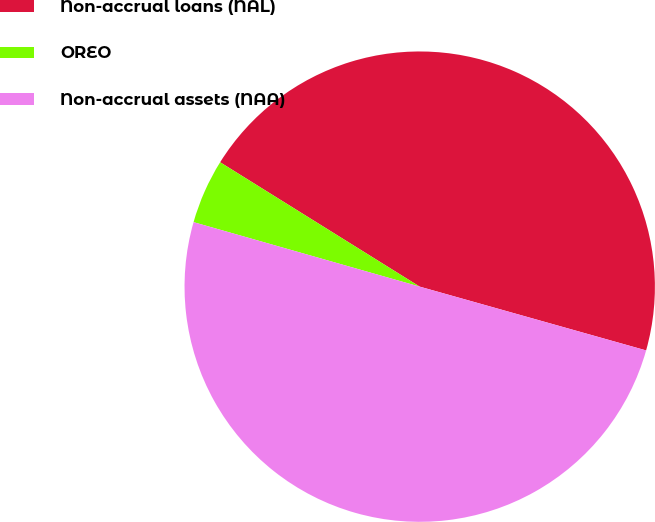<chart> <loc_0><loc_0><loc_500><loc_500><pie_chart><fcel>Non-accrual loans (NAL)<fcel>OREO<fcel>Non-accrual assets (NAA)<nl><fcel>45.5%<fcel>4.45%<fcel>50.05%<nl></chart> 